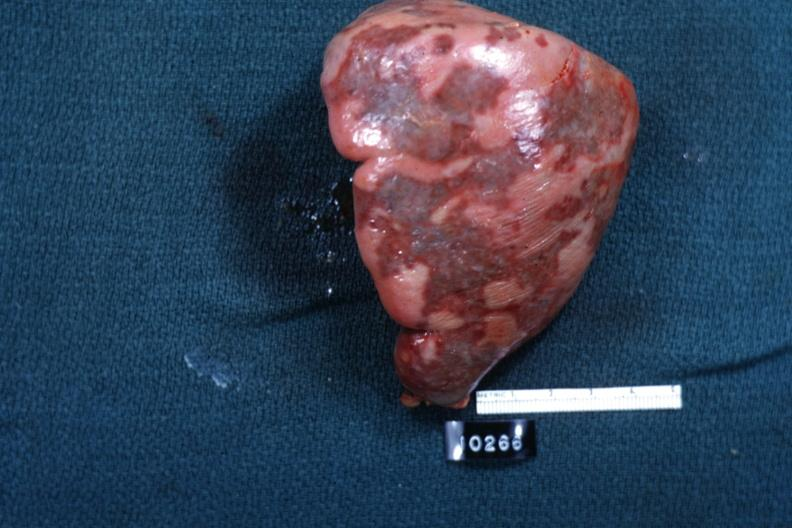does this image show external view of spleen with multiple recent infarcts cut surface is slide?
Answer the question using a single word or phrase. Yes 